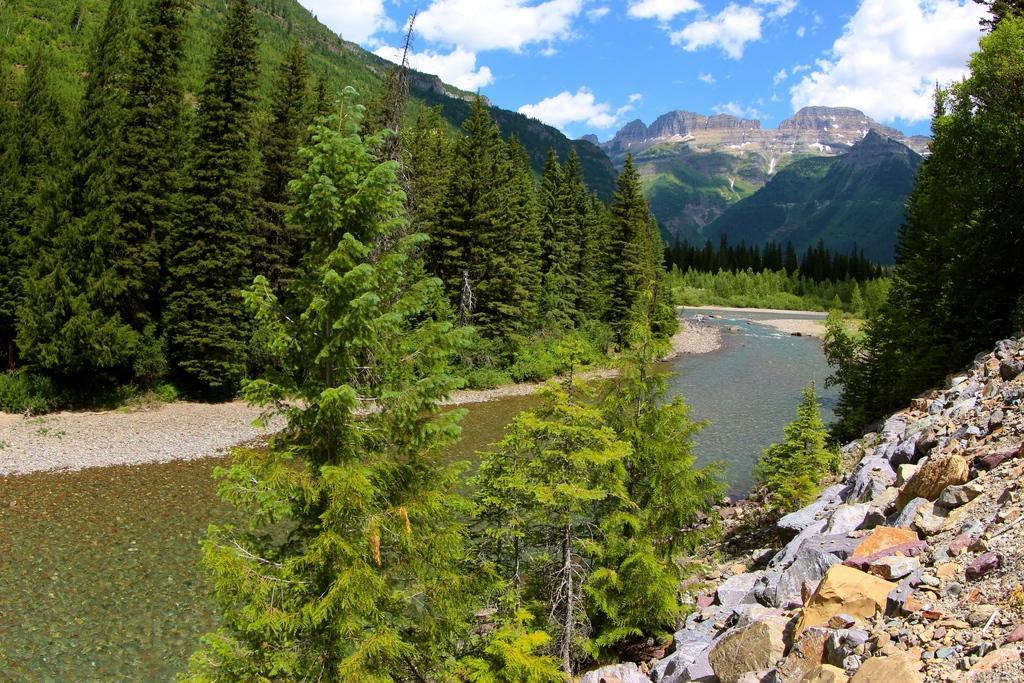Please provide a concise description of this image. Here in this picture we can see mountains present all over there and we can see the ground is covered with plants and trees all over there and in the middle we can see water flowing over a path and we can see some rock stones here and there and we can see clouds in the sky. 